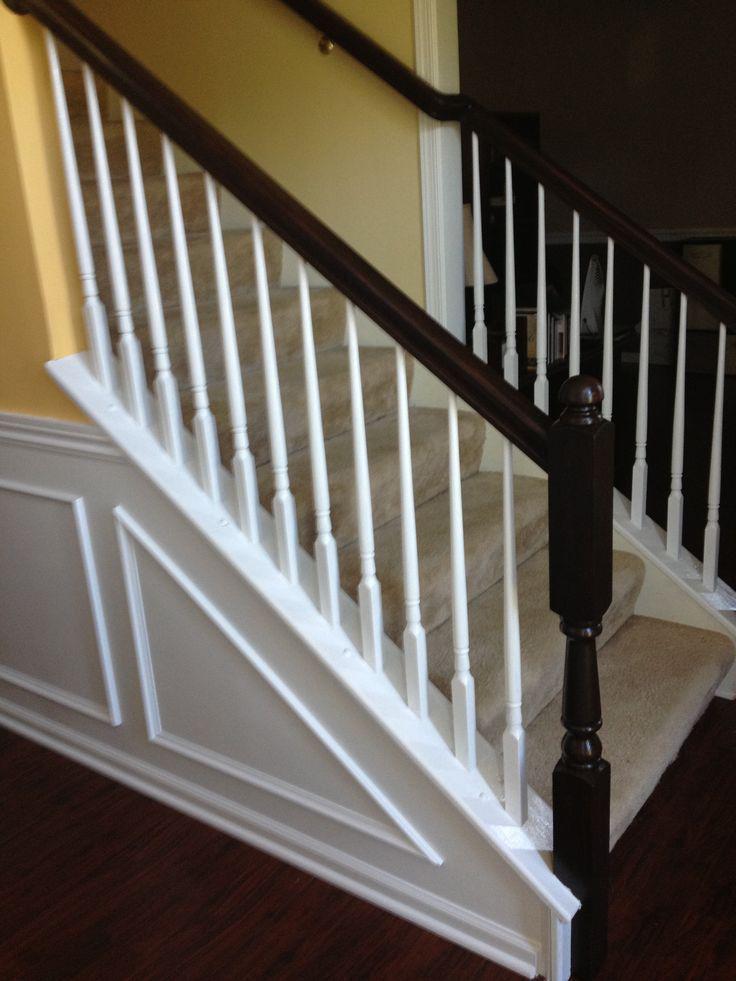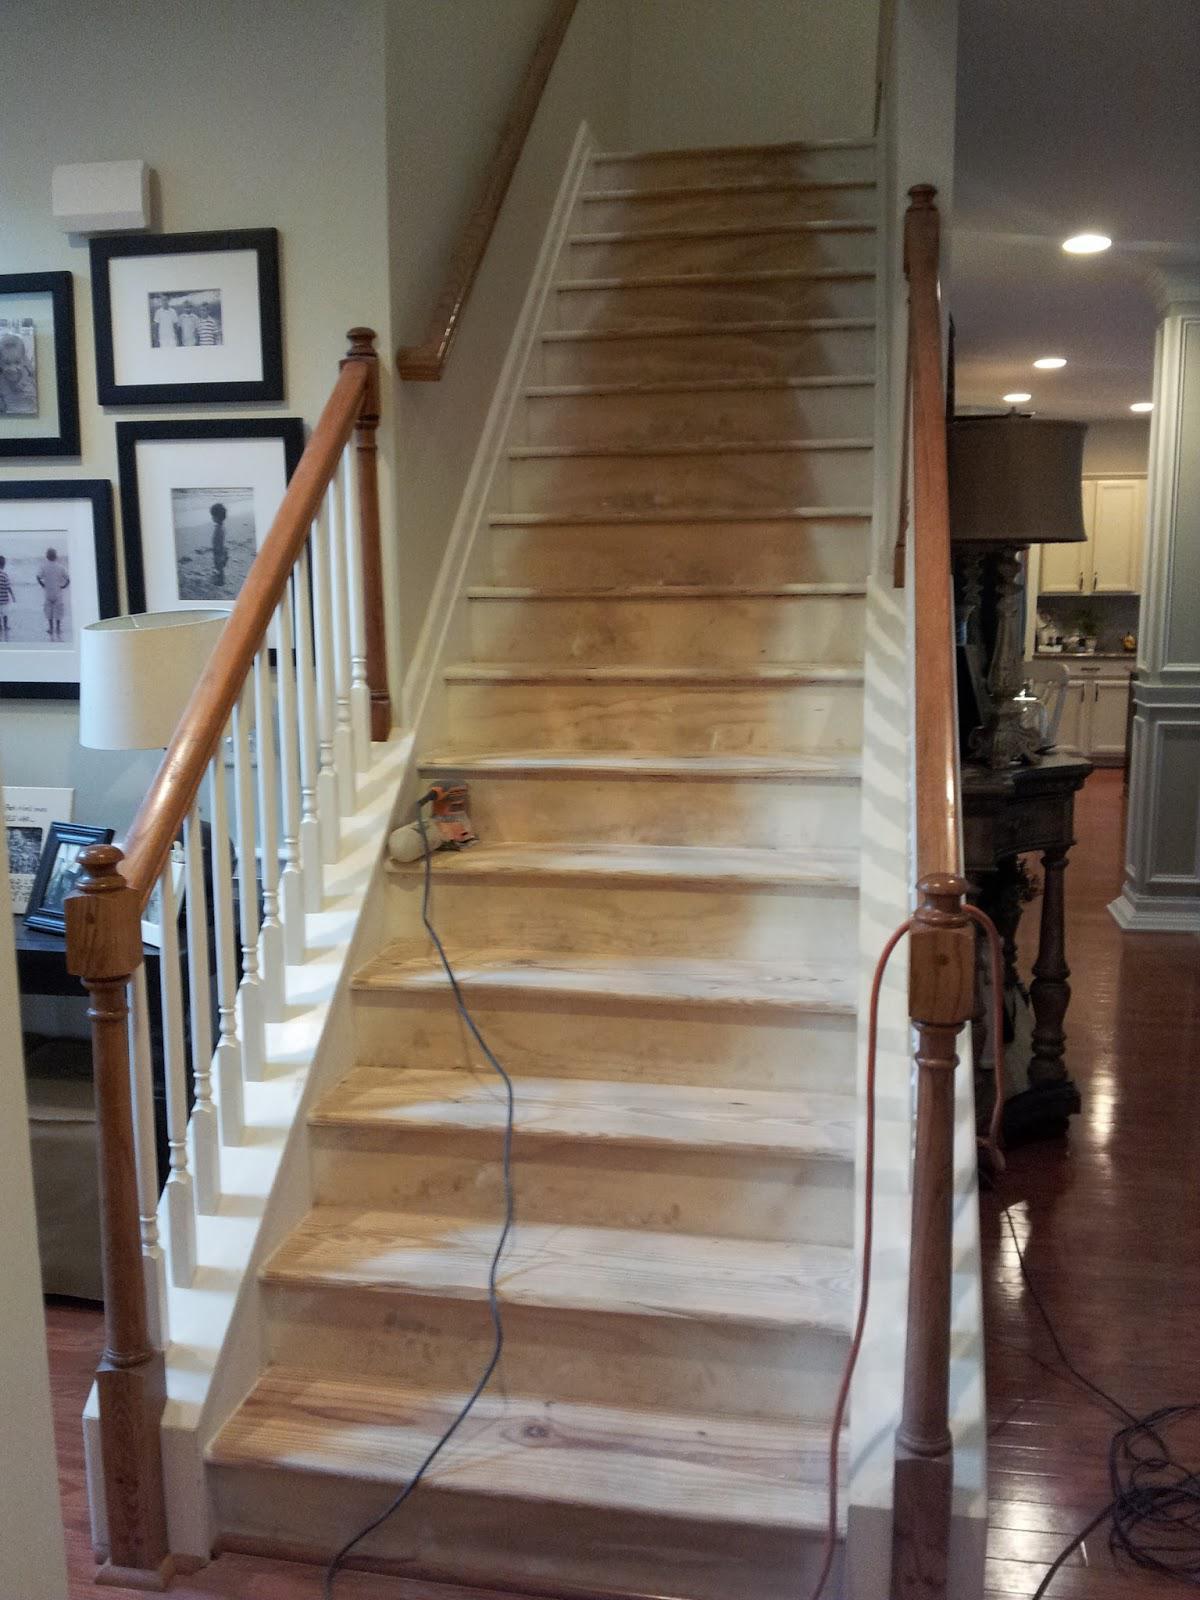The first image is the image on the left, the second image is the image on the right. Examine the images to the left and right. Is the description "There are at least two l-shaped staircases." accurate? Answer yes or no. No. The first image is the image on the left, the second image is the image on the right. For the images shown, is this caption "An image shows an ascending non-curved staircase with beige carpeted steps, dark handrails with a ball-topped corner post, and white vertical bars." true? Answer yes or no. Yes. 